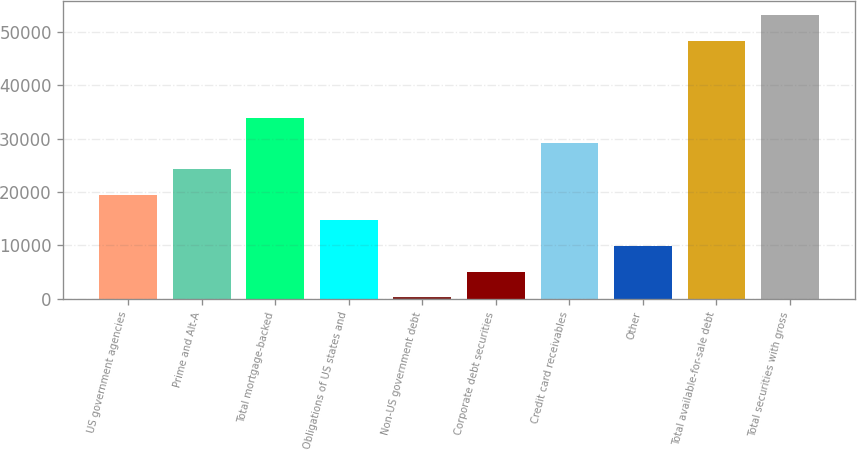<chart> <loc_0><loc_0><loc_500><loc_500><bar_chart><fcel>US government agencies<fcel>Prime and Alt-A<fcel>Total mortgage-backed<fcel>Obligations of US states and<fcel>Non-US government debt<fcel>Corporate debt securities<fcel>Credit card receivables<fcel>Other<fcel>Total available-for-sale debt<fcel>Total securities with gross<nl><fcel>19509.2<fcel>24309.5<fcel>33910.1<fcel>14708.9<fcel>308<fcel>5108.3<fcel>29109.8<fcel>9908.6<fcel>48292<fcel>53092.3<nl></chart> 